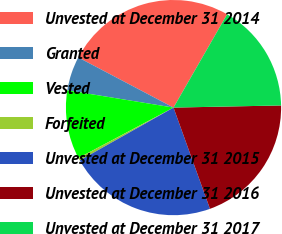Convert chart to OTSL. <chart><loc_0><loc_0><loc_500><loc_500><pie_chart><fcel>Unvested at December 31 2014<fcel>Granted<fcel>Vested<fcel>Forfeited<fcel>Unvested at December 31 2015<fcel>Unvested at December 31 2016<fcel>Unvested at December 31 2017<nl><fcel>25.59%<fcel>5.14%<fcel>10.33%<fcel>0.41%<fcel>22.33%<fcel>19.81%<fcel>16.38%<nl></chart> 